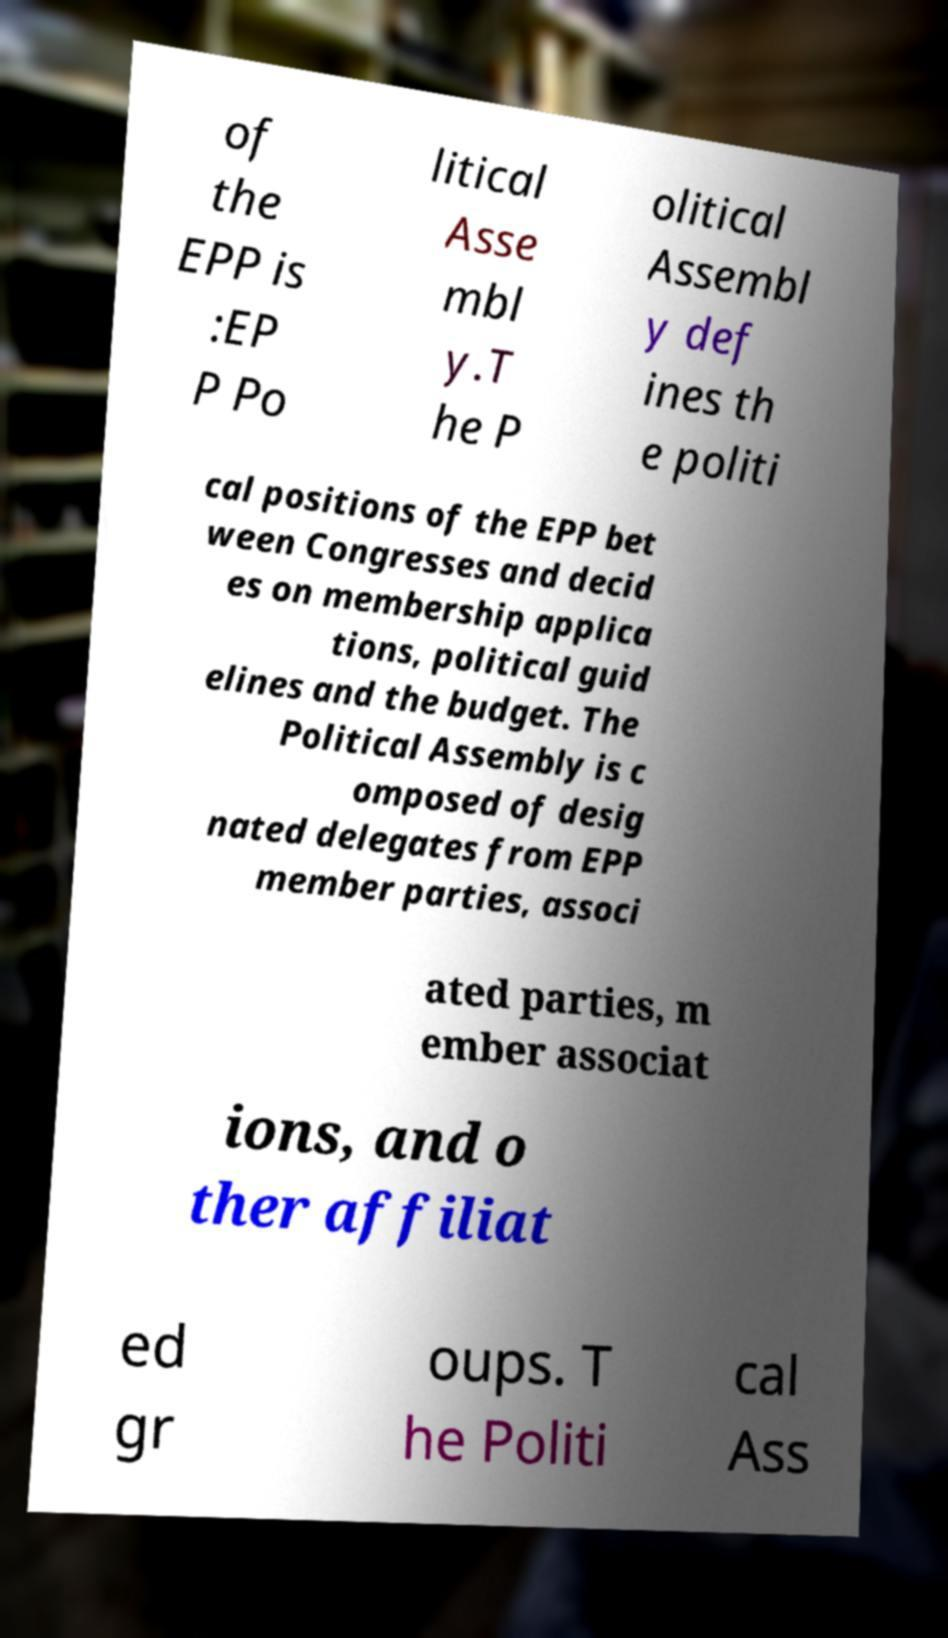Can you accurately transcribe the text from the provided image for me? of the EPP is :EP P Po litical Asse mbl y.T he P olitical Assembl y def ines th e politi cal positions of the EPP bet ween Congresses and decid es on membership applica tions, political guid elines and the budget. The Political Assembly is c omposed of desig nated delegates from EPP member parties, associ ated parties, m ember associat ions, and o ther affiliat ed gr oups. T he Politi cal Ass 